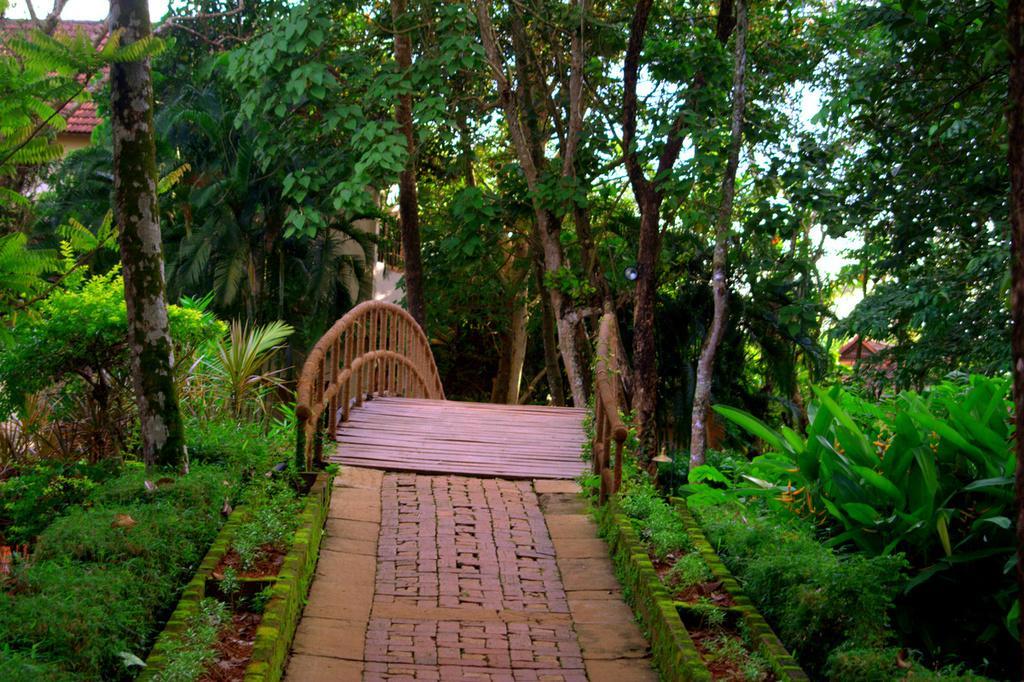Can you describe this image briefly? In this picture there is wooden bridge in the center of the image and there is greenery in the image, there are houses in the background area of the image. 